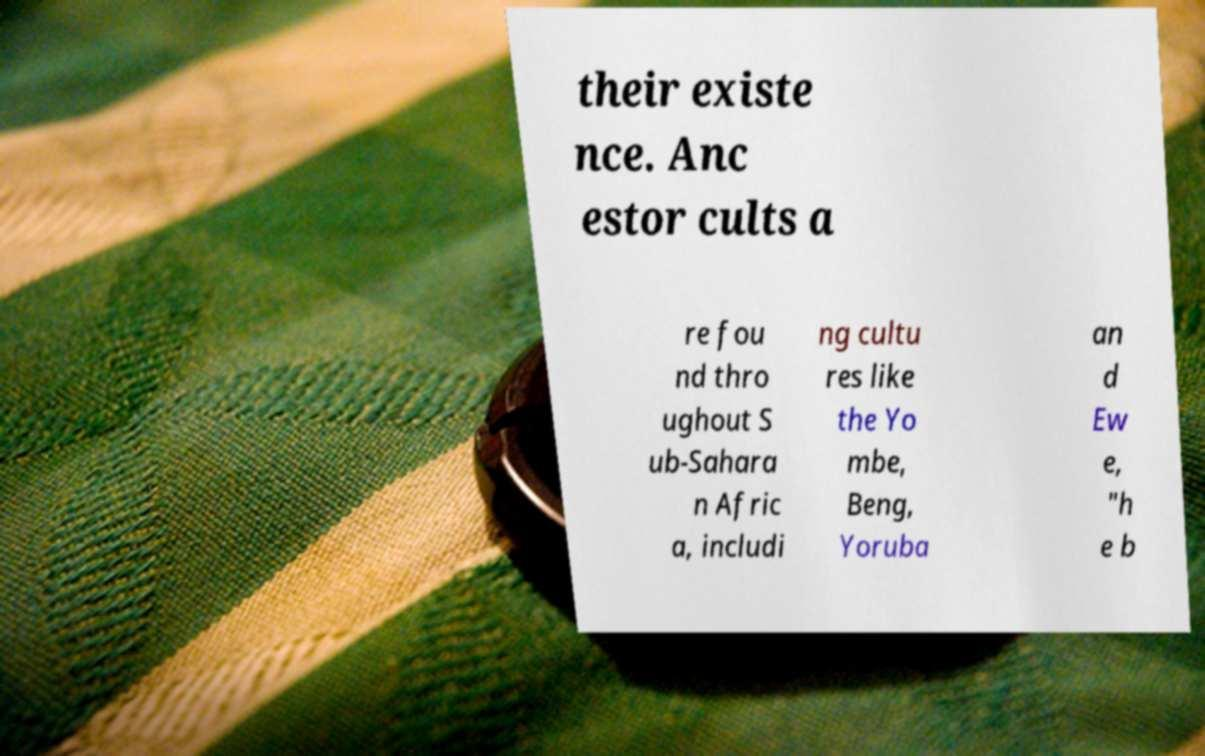Please identify and transcribe the text found in this image. their existe nce. Anc estor cults a re fou nd thro ughout S ub-Sahara n Afric a, includi ng cultu res like the Yo mbe, Beng, Yoruba an d Ew e, "h e b 